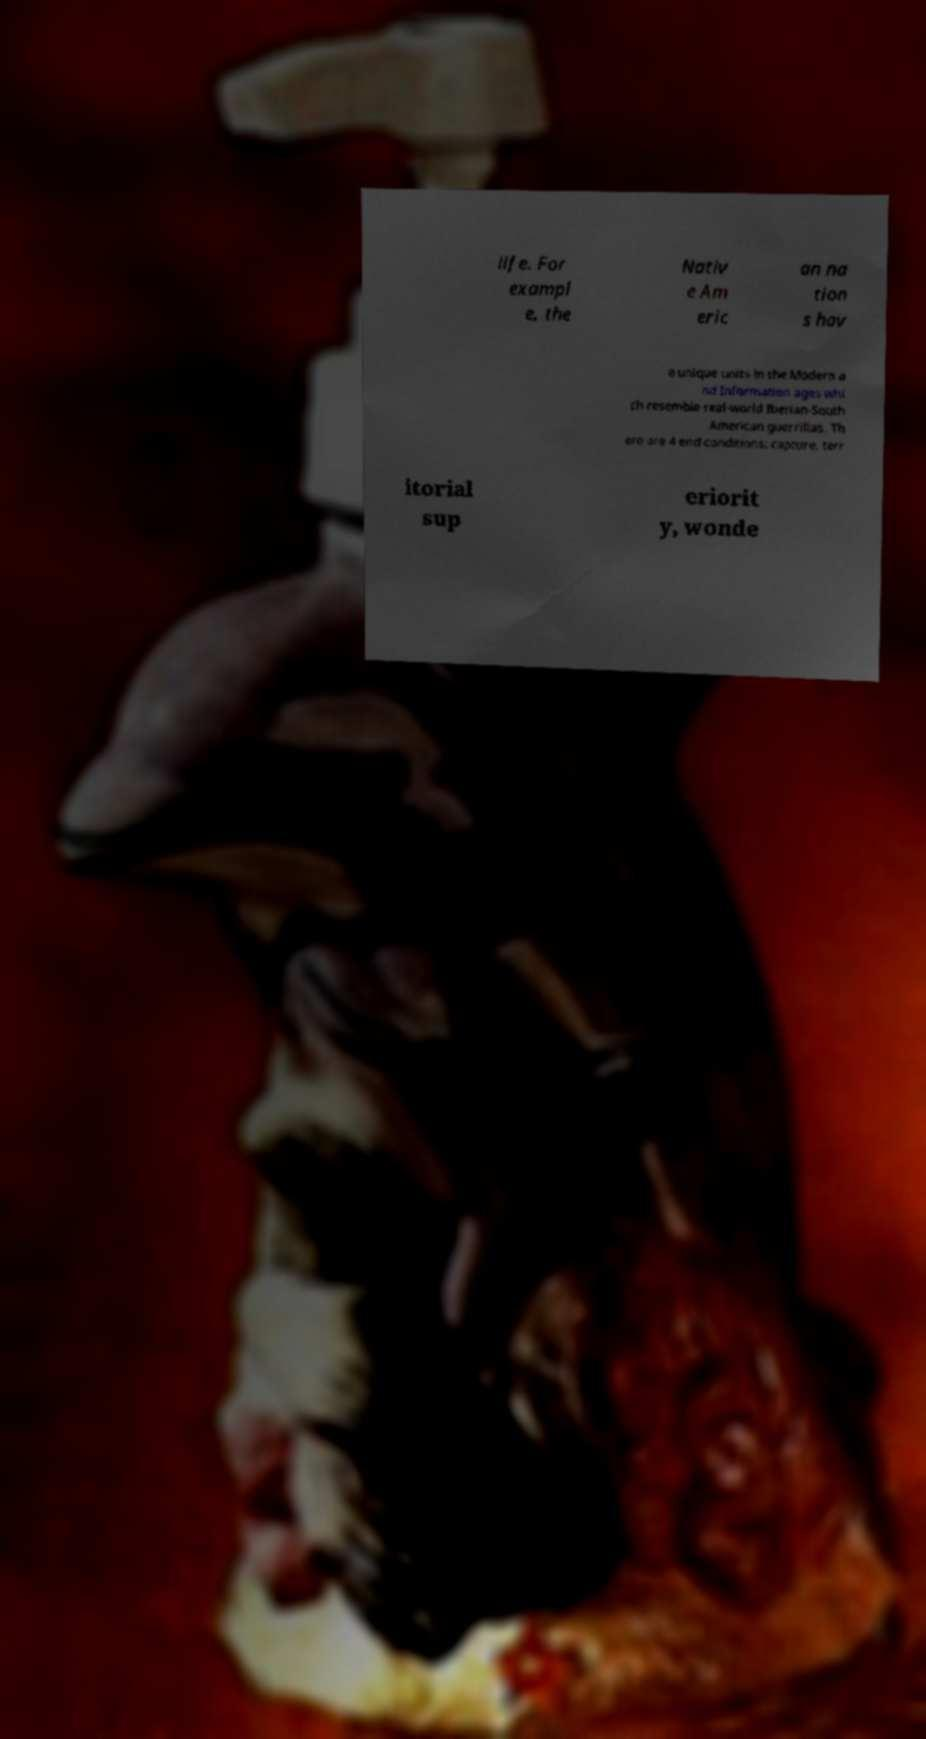There's text embedded in this image that I need extracted. Can you transcribe it verbatim? life. For exampl e, the Nativ e Am eric an na tion s hav e unique units in the Modern a nd Information ages whi ch resemble real-world Iberian-South American guerrillas. Th ere are 4 end conditions: capture, terr itorial sup eriorit y, wonde 